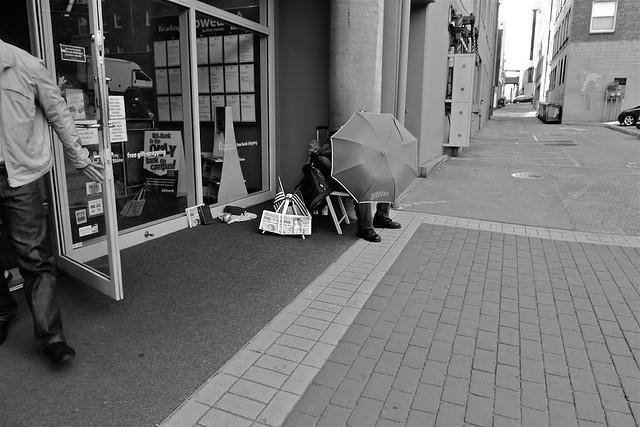How many umbrellas are pictured?
Answer briefly. 1. Is there a person behind the umbrella?
Concise answer only. Yes. Is this an alley?
Concise answer only. Yes. Does this establishment have WiFi?
Give a very brief answer. Yes. Is this photo in color?
Keep it brief. No. 